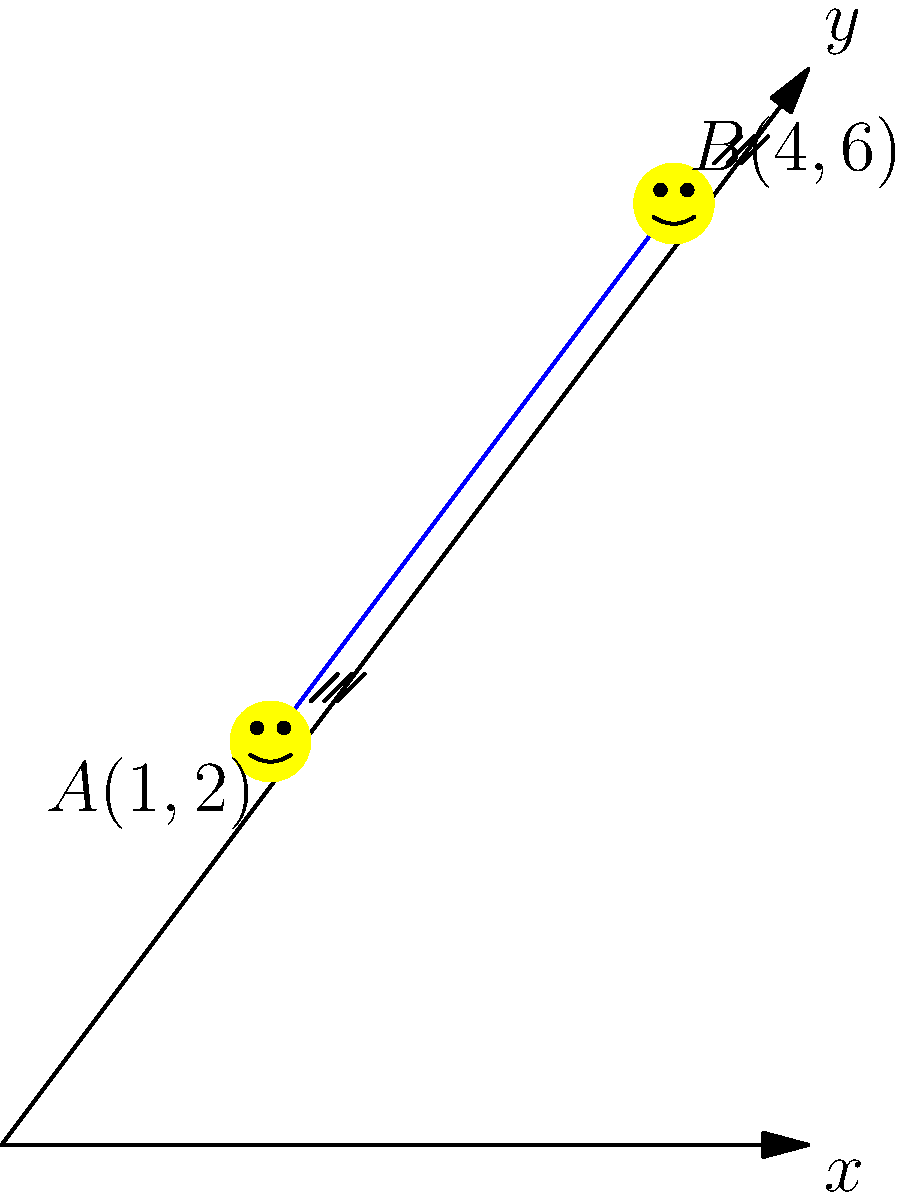Two sneezing faces are located at points $A(1,2)$ and $B(4,6)$ on a coordinate plane. Find the equation of the line passing through these two allergy-ridden points. Express your answer in slope-intercept form $(y = mx + b)$. To find the equation of the line passing through two points, we'll follow these steps:

1) Calculate the slope $(m)$ using the slope formula:
   $m = \frac{y_2 - y_1}{x_2 - x_1} = \frac{6 - 2}{4 - 1} = \frac{4}{3}$

2) Use the point-slope form of a line with point $A(1,2)$:
   $y - y_1 = m(x - x_1)$
   $y - 2 = \frac{4}{3}(x - 1)$

3) Distribute the $\frac{4}{3}$:
   $y - 2 = \frac{4}{3}x - \frac{4}{3}$

4) Add 2 to both sides to isolate $y$:
   $y = \frac{4}{3}x - \frac{4}{3} + 2$

5) Simplify:
   $y = \frac{4}{3}x + \frac{2}{3}$

This is now in slope-intercept form $(y = mx + b)$, where $m = \frac{4}{3}$ and $b = \frac{2}{3}$.
Answer: $y = \frac{4}{3}x + \frac{2}{3}$ 